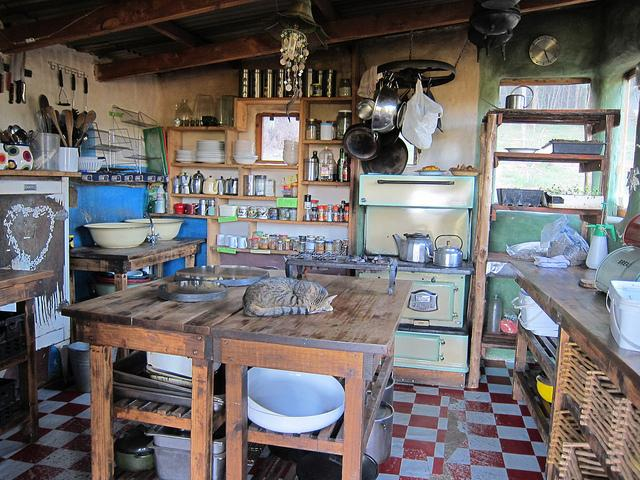What is in the kitchen but unnecessary for cooking or baking? Please explain your reasoning. cat. The cat isn't needed to bake or cook. 